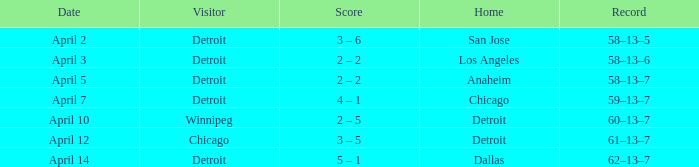Which was the host team in the match featuring a guest from chicago? Detroit. 